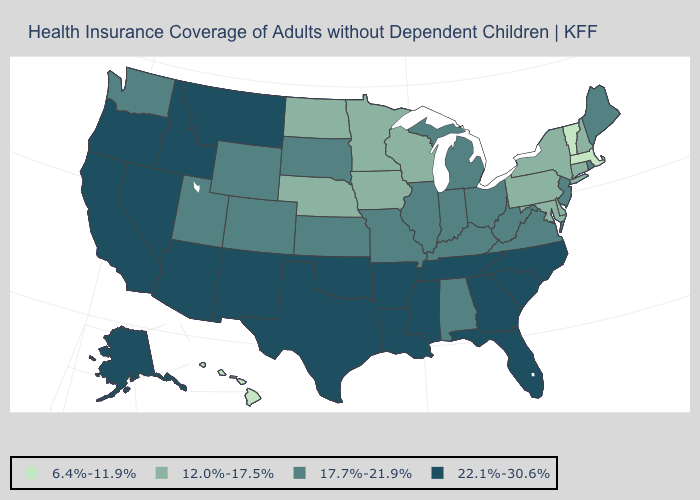What is the value of Pennsylvania?
Quick response, please. 12.0%-17.5%. What is the value of California?
Write a very short answer. 22.1%-30.6%. Is the legend a continuous bar?
Write a very short answer. No. Among the states that border Nevada , which have the lowest value?
Quick response, please. Utah. Does the first symbol in the legend represent the smallest category?
Concise answer only. Yes. Does Oklahoma have the same value as North Dakota?
Quick response, please. No. What is the highest value in states that border Wisconsin?
Give a very brief answer. 17.7%-21.9%. Does Washington have the same value as Louisiana?
Keep it brief. No. Does New Mexico have the highest value in the West?
Quick response, please. Yes. Which states have the lowest value in the MidWest?
Short answer required. Iowa, Minnesota, Nebraska, North Dakota, Wisconsin. What is the value of Wyoming?
Quick response, please. 17.7%-21.9%. What is the value of Rhode Island?
Short answer required. 17.7%-21.9%. What is the lowest value in the West?
Answer briefly. 6.4%-11.9%. Does the first symbol in the legend represent the smallest category?
Keep it brief. Yes. What is the value of Mississippi?
Quick response, please. 22.1%-30.6%. 